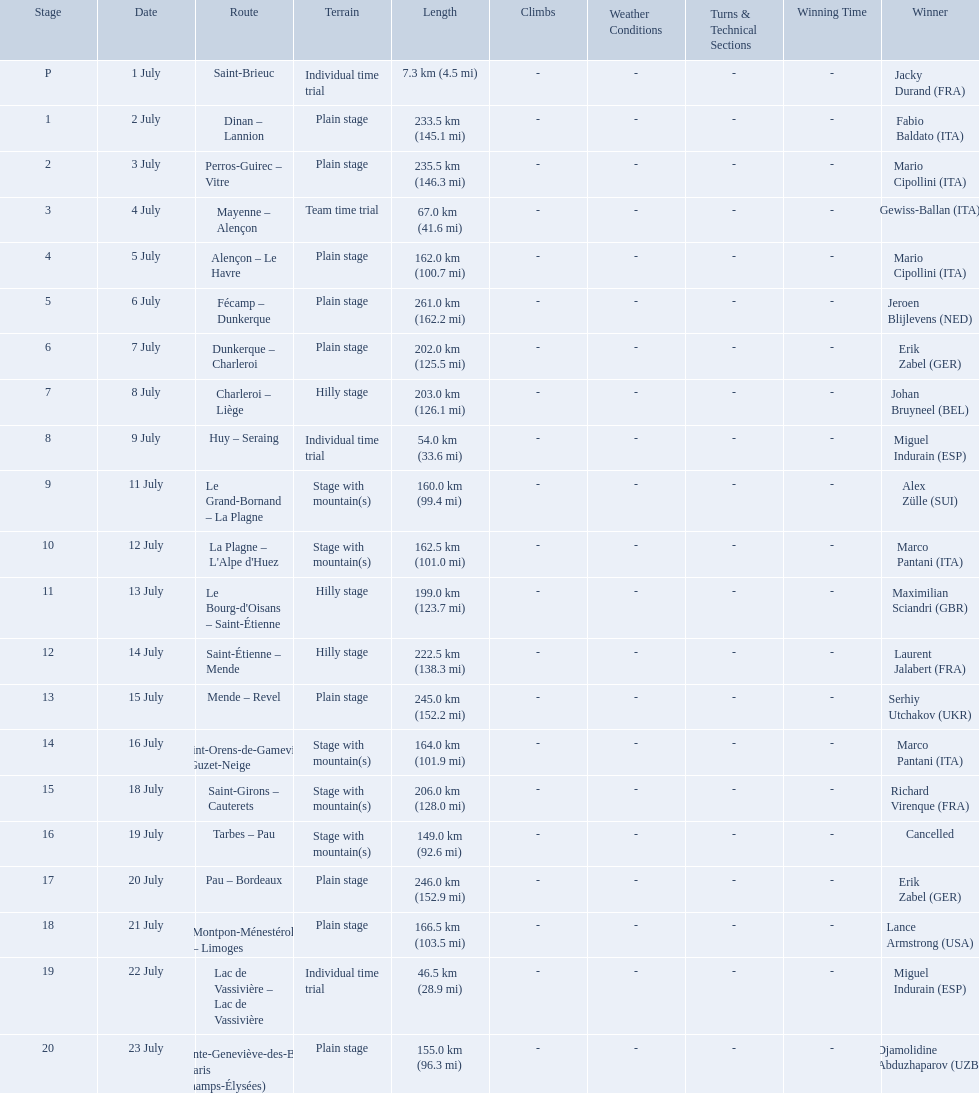What are the dates? 1 July, 2 July, 3 July, 4 July, 5 July, 6 July, 7 July, 8 July, 9 July, 11 July, 12 July, 13 July, 14 July, 15 July, 16 July, 18 July, 19 July, 20 July, 21 July, 22 July, 23 July. What is the length on 8 july? 203.0 km (126.1 mi). What were the lengths of all the stages of the 1995 tour de france? 7.3 km (4.5 mi), 233.5 km (145.1 mi), 235.5 km (146.3 mi), 67.0 km (41.6 mi), 162.0 km (100.7 mi), 261.0 km (162.2 mi), 202.0 km (125.5 mi), 203.0 km (126.1 mi), 54.0 km (33.6 mi), 160.0 km (99.4 mi), 162.5 km (101.0 mi), 199.0 km (123.7 mi), 222.5 km (138.3 mi), 245.0 km (152.2 mi), 164.0 km (101.9 mi), 206.0 km (128.0 mi), 149.0 km (92.6 mi), 246.0 km (152.9 mi), 166.5 km (103.5 mi), 46.5 km (28.9 mi), 155.0 km (96.3 mi). Of those, which one occurred on july 8th? 203.0 km (126.1 mi). 